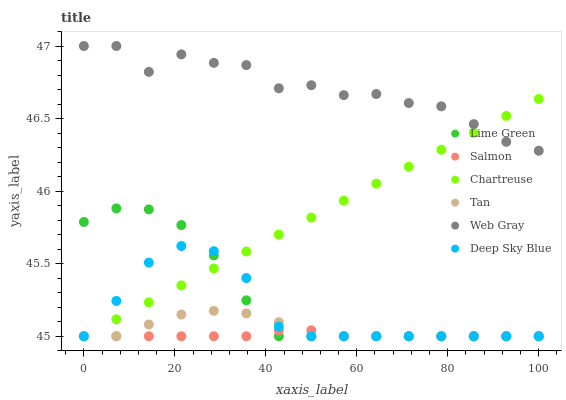Does Salmon have the minimum area under the curve?
Answer yes or no. Yes. Does Web Gray have the maximum area under the curve?
Answer yes or no. Yes. Does Chartreuse have the minimum area under the curve?
Answer yes or no. No. Does Chartreuse have the maximum area under the curve?
Answer yes or no. No. Is Chartreuse the smoothest?
Answer yes or no. Yes. Is Web Gray the roughest?
Answer yes or no. Yes. Is Salmon the smoothest?
Answer yes or no. No. Is Salmon the roughest?
Answer yes or no. No. Does Salmon have the lowest value?
Answer yes or no. Yes. Does Web Gray have the highest value?
Answer yes or no. Yes. Does Chartreuse have the highest value?
Answer yes or no. No. Is Lime Green less than Web Gray?
Answer yes or no. Yes. Is Web Gray greater than Lime Green?
Answer yes or no. Yes. Does Tan intersect Chartreuse?
Answer yes or no. Yes. Is Tan less than Chartreuse?
Answer yes or no. No. Is Tan greater than Chartreuse?
Answer yes or no. No. Does Lime Green intersect Web Gray?
Answer yes or no. No. 